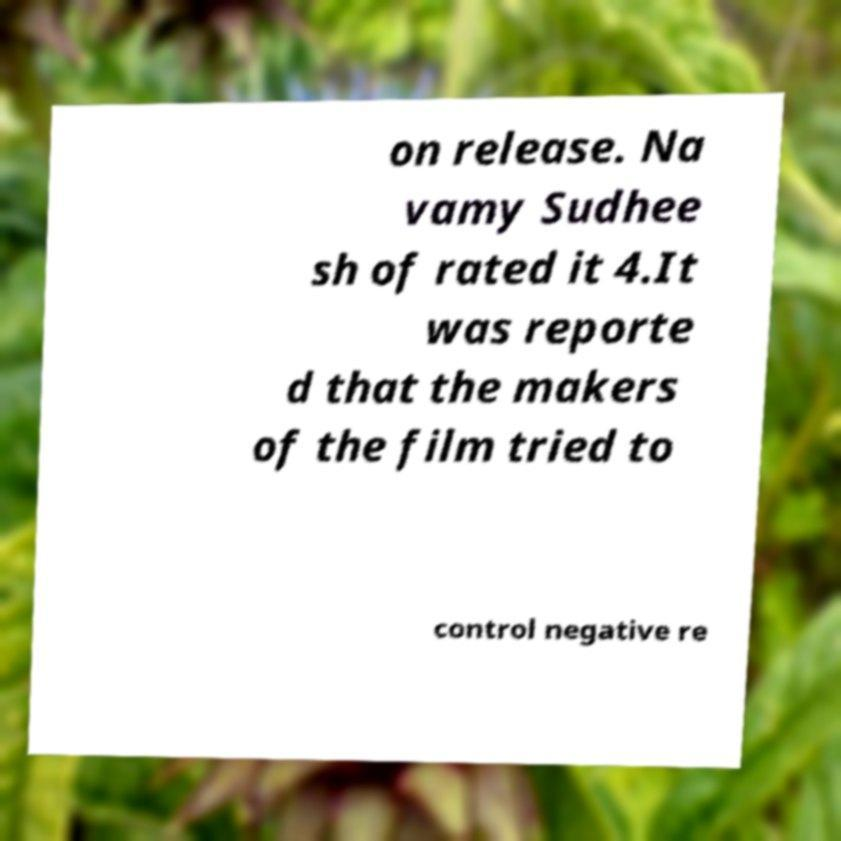Could you extract and type out the text from this image? on release. Na vamy Sudhee sh of rated it 4.It was reporte d that the makers of the film tried to control negative re 